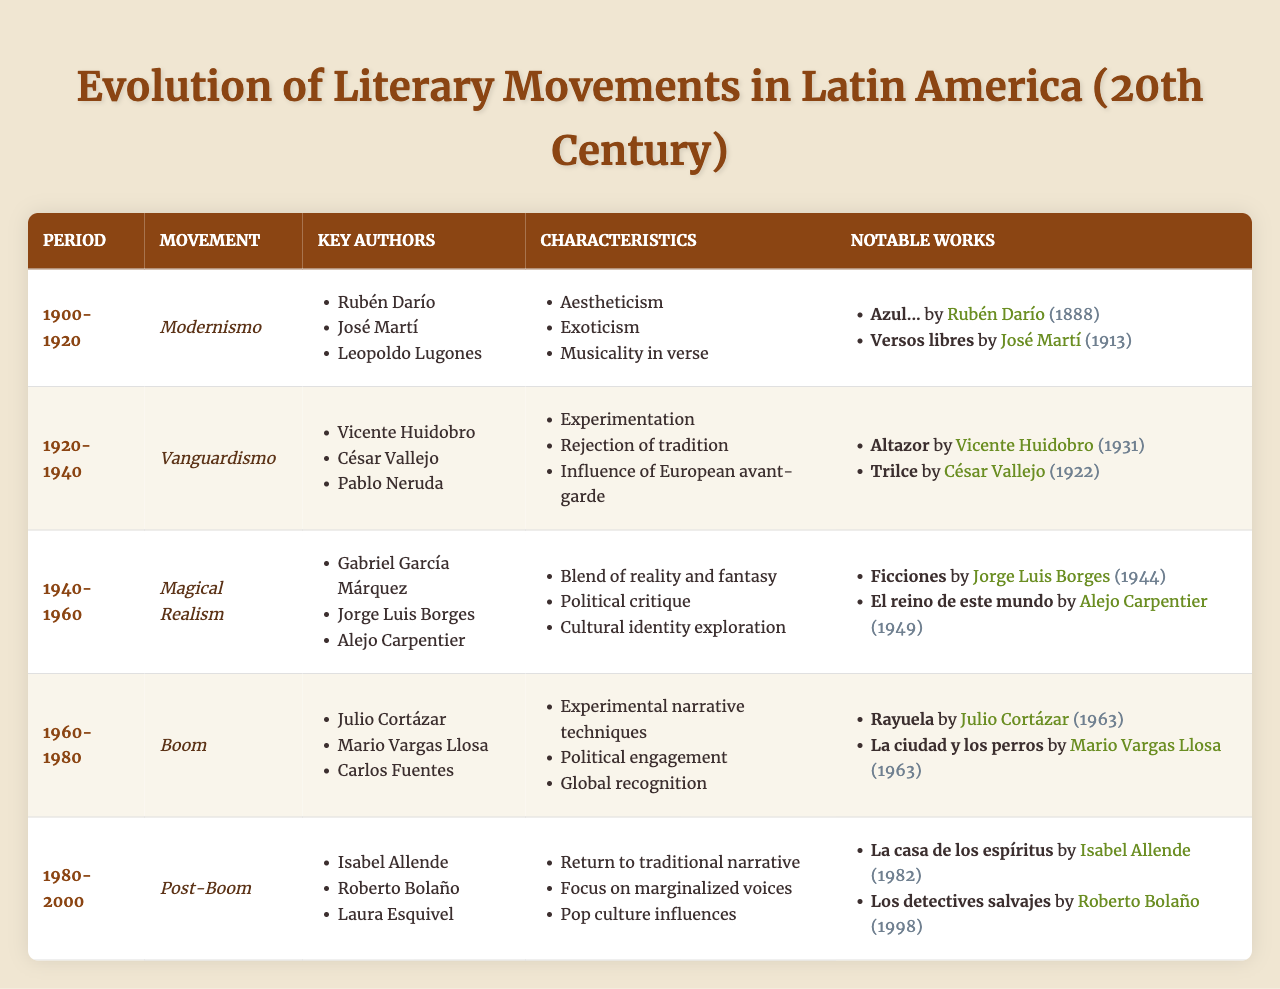What literary movement spanned from 1920 to 1940? The table indicates that the movement during this period is named "Vanguardismo."
Answer: Vanguardismo Which author is associated with the notable work "Rayuela"? According to the table, "Rayuela" is a notable work by Julio Cortázar.
Answer: Julio Cortázar How many key authors are listed for the "Boom" movement? The table shows that there are three key authors listed for the "Boom" movement: Julio Cortázar, Mario Vargas Llosa, and Carlos Fuentes.
Answer: Three Is "Magical Realism" characterized by political critique? Yes, the table specifies that one of the characteristics of "Magical Realism" is political critique.
Answer: Yes What is the title of a notable work of "Modernismo" published after 1900? From the table, "Versos libres" by José Martí, published in 1913, is a notable work of "Modernismo" after 1900.
Answer: Versos libres Which literary movement features key authors like Gabriel García Márquez and Jorge Luis Borges? The table states that "Magical Realism" features these key authors.
Answer: Magical Realism What notable work was published in 1944? According to the table, "Ficciones" by Jorge Luis Borges was published in 1944.
Answer: Ficciones Which movement focused on marginalized voices and had authors influenced by pop culture? The table indicates that the "Post-Boom" movement focused on marginalized voices and had pop culture influences.
Answer: Post-Boom How many distinct movements are listed in the table? There are five distinct movements listed in the table: Modernismo, Vanguardismo, Magical Realism, Boom, and Post-Boom.
Answer: Five Which movement includes the characteristic of "rejection of tradition"? The characteristic of "rejection of tradition" is included under the "Vanguardismo" movement according to the table.
Answer: Vanguardismo What is the relationship between the period 1960-1980 and the literary movement discussed? The period 1960-1980 is associated with the "Boom" movement as per the table.
Answer: Boom What notable work published in 1982 is associated with the "Post-Boom"? The table lists "La casa de los espíritus" by Isabel Allende as a notable work published in 1982 associated with the "Post-Boom."
Answer: La casa de los espíritus 